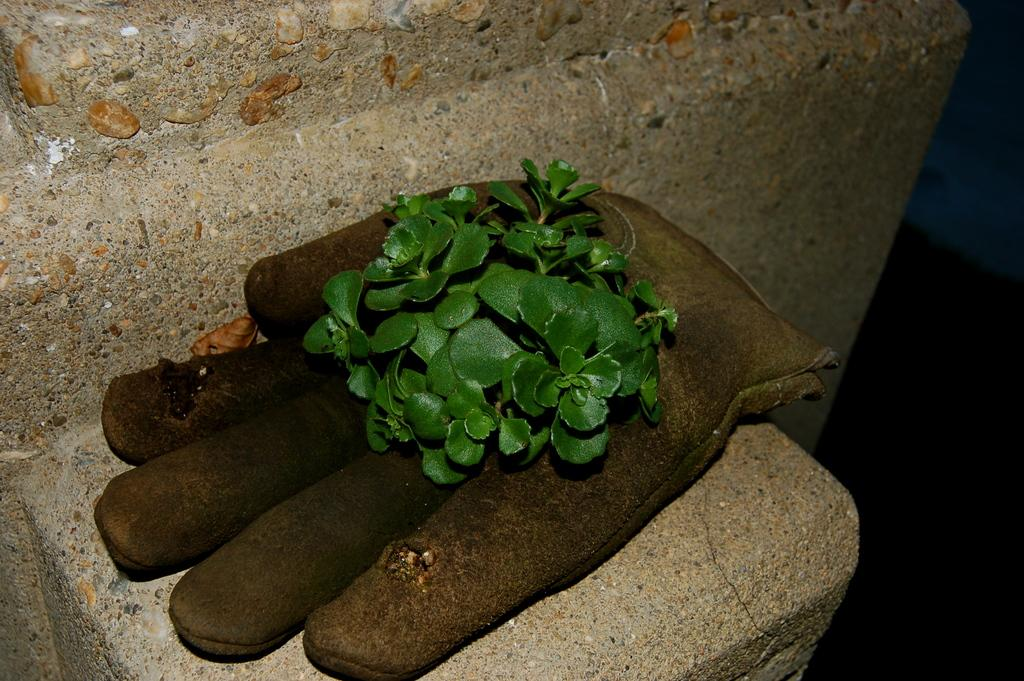What is present in the image? There is a plant in the image. Where is the plant located? The plant is on an object. What can be seen in the background of the image? There is a wall in the background of the image. What type of bread is being used to support the plant in the image? There is no bread present in the image; the plant is on an unspecified object. 